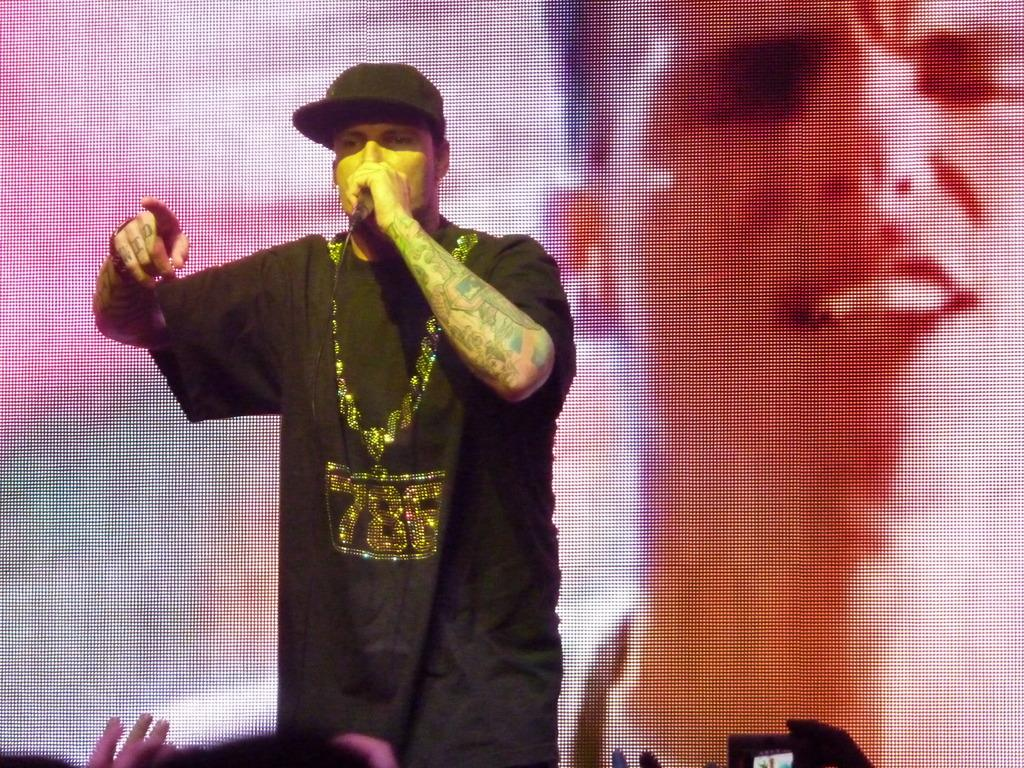What is the main subject of the image? There is a person in the image. What is the person wearing on their upper body? The person is wearing a black t-shirt. What activity is the person engaged in? The person is singing. What type of headwear is the person wearing? The person is wearing a black hat. How many rabbits are hopping around the person in the image? There are no rabbits present in the image. What type of ring is the person wearing on their finger? The person is not wearing a ring in the image. 